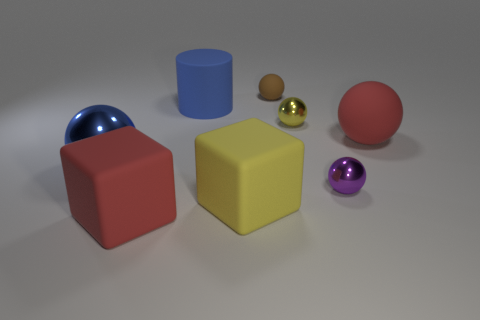Do the large metallic object and the matte cylinder have the same color?
Ensure brevity in your answer.  Yes. How many blocks are tiny green shiny things or yellow objects?
Your answer should be very brief. 1. What number of red rubber objects are behind the big red matte object that is left of the big yellow thing?
Make the answer very short. 1. Is the tiny yellow ball made of the same material as the cylinder?
Keep it short and to the point. No. What size is the matte object that is the same color as the big rubber sphere?
Your answer should be very brief. Large. Is there a object that has the same material as the red ball?
Offer a terse response. Yes. The small object in front of the small metal sphere that is behind the red thing that is right of the big red matte block is what color?
Provide a succinct answer. Purple. How many cyan things are either matte balls or small shiny objects?
Keep it short and to the point. 0. What number of big yellow things have the same shape as the brown object?
Your response must be concise. 0. There is a yellow object that is the same size as the red block; what is its shape?
Your response must be concise. Cube. 